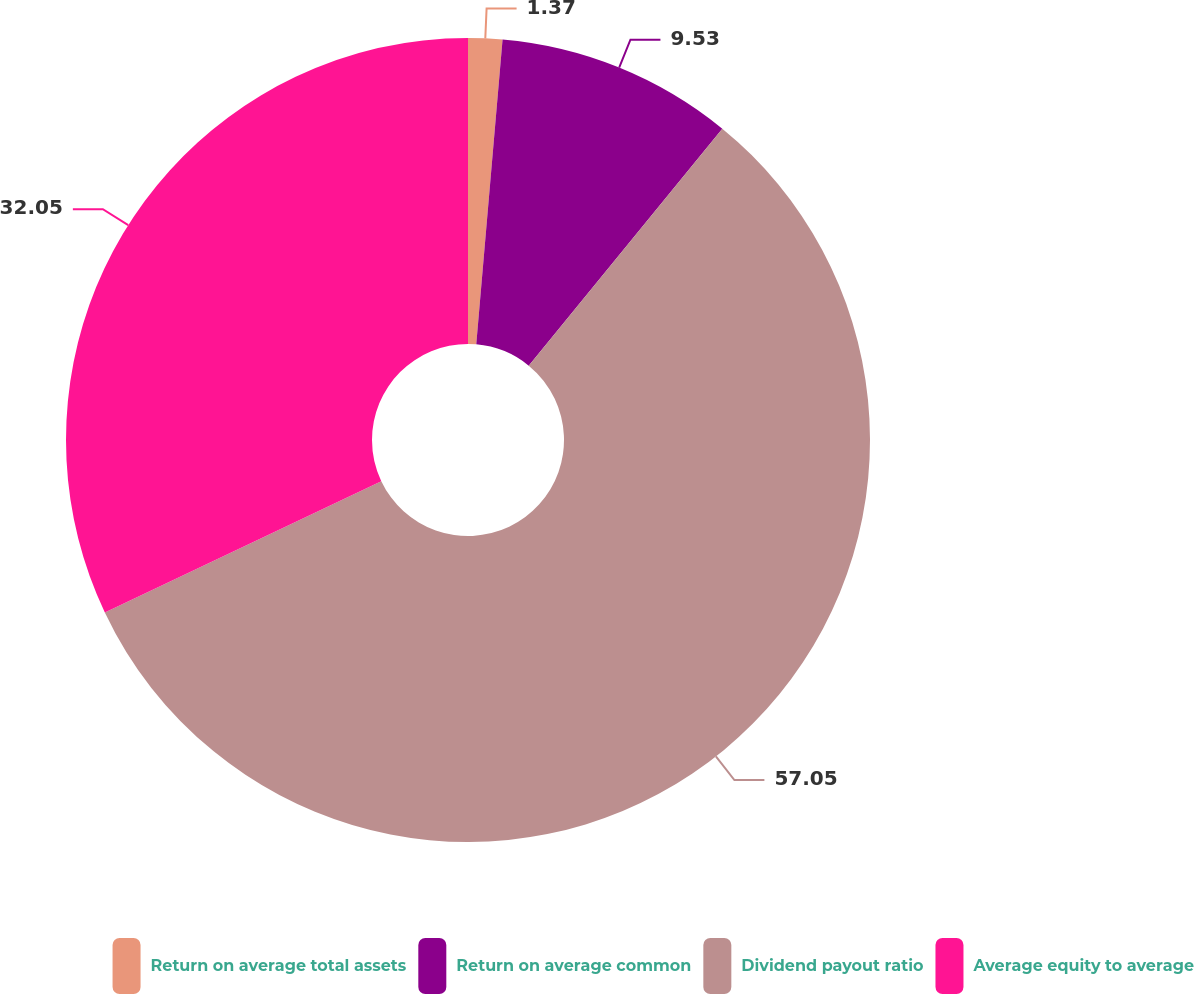Convert chart. <chart><loc_0><loc_0><loc_500><loc_500><pie_chart><fcel>Return on average total assets<fcel>Return on average common<fcel>Dividend payout ratio<fcel>Average equity to average<nl><fcel>1.37%<fcel>9.53%<fcel>57.04%<fcel>32.05%<nl></chart> 